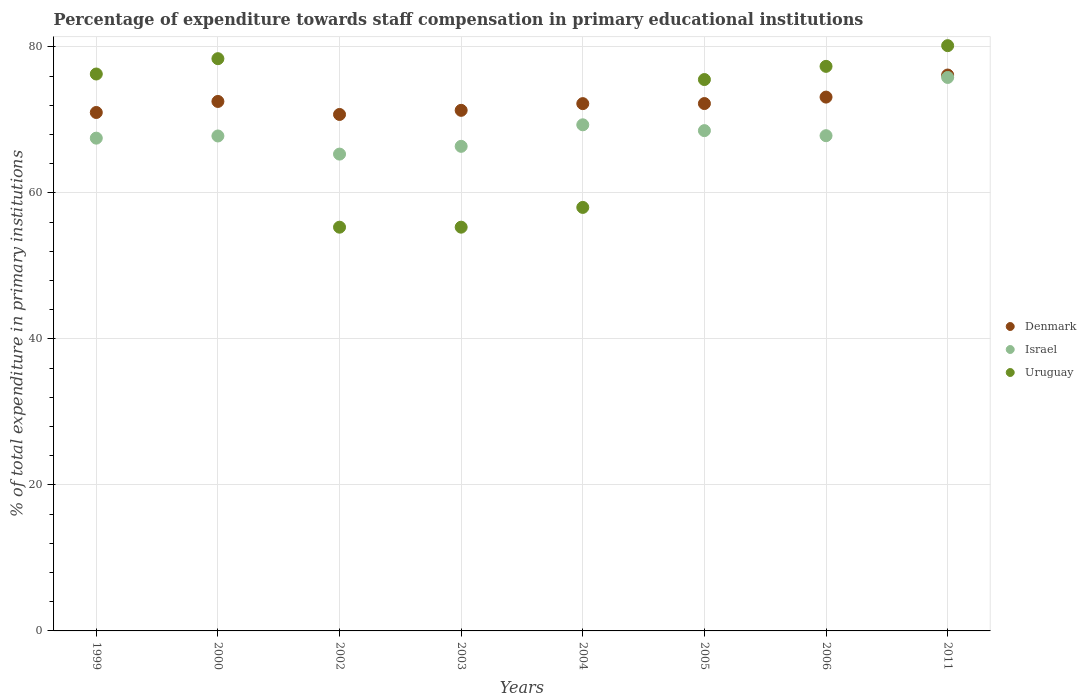How many different coloured dotlines are there?
Keep it short and to the point. 3. What is the percentage of expenditure towards staff compensation in Uruguay in 2004?
Offer a terse response. 58.01. Across all years, what is the maximum percentage of expenditure towards staff compensation in Uruguay?
Make the answer very short. 80.17. Across all years, what is the minimum percentage of expenditure towards staff compensation in Uruguay?
Provide a short and direct response. 55.3. In which year was the percentage of expenditure towards staff compensation in Uruguay maximum?
Make the answer very short. 2011. What is the total percentage of expenditure towards staff compensation in Israel in the graph?
Your response must be concise. 548.5. What is the difference between the percentage of expenditure towards staff compensation in Israel in 2002 and that in 2006?
Your response must be concise. -2.52. What is the difference between the percentage of expenditure towards staff compensation in Denmark in 2003 and the percentage of expenditure towards staff compensation in Israel in 1999?
Provide a short and direct response. 3.81. What is the average percentage of expenditure towards staff compensation in Uruguay per year?
Ensure brevity in your answer.  69.54. In the year 2003, what is the difference between the percentage of expenditure towards staff compensation in Uruguay and percentage of expenditure towards staff compensation in Israel?
Offer a very short reply. -11.07. What is the ratio of the percentage of expenditure towards staff compensation in Denmark in 2005 to that in 2011?
Your response must be concise. 0.95. Is the difference between the percentage of expenditure towards staff compensation in Uruguay in 1999 and 2004 greater than the difference between the percentage of expenditure towards staff compensation in Israel in 1999 and 2004?
Ensure brevity in your answer.  Yes. What is the difference between the highest and the second highest percentage of expenditure towards staff compensation in Israel?
Provide a succinct answer. 6.49. What is the difference between the highest and the lowest percentage of expenditure towards staff compensation in Israel?
Your answer should be compact. 10.5. Is the sum of the percentage of expenditure towards staff compensation in Denmark in 2000 and 2004 greater than the maximum percentage of expenditure towards staff compensation in Israel across all years?
Give a very brief answer. Yes. Is it the case that in every year, the sum of the percentage of expenditure towards staff compensation in Uruguay and percentage of expenditure towards staff compensation in Denmark  is greater than the percentage of expenditure towards staff compensation in Israel?
Provide a succinct answer. Yes. How many years are there in the graph?
Offer a terse response. 8. Are the values on the major ticks of Y-axis written in scientific E-notation?
Your response must be concise. No. Does the graph contain grids?
Ensure brevity in your answer.  Yes. How many legend labels are there?
Your answer should be very brief. 3. How are the legend labels stacked?
Give a very brief answer. Vertical. What is the title of the graph?
Provide a succinct answer. Percentage of expenditure towards staff compensation in primary educational institutions. Does "Ghana" appear as one of the legend labels in the graph?
Offer a very short reply. No. What is the label or title of the X-axis?
Your response must be concise. Years. What is the label or title of the Y-axis?
Provide a short and direct response. % of total expenditure in primary institutions. What is the % of total expenditure in primary institutions of Denmark in 1999?
Make the answer very short. 71.01. What is the % of total expenditure in primary institutions in Israel in 1999?
Provide a short and direct response. 67.5. What is the % of total expenditure in primary institutions of Uruguay in 1999?
Your answer should be very brief. 76.29. What is the % of total expenditure in primary institutions in Denmark in 2000?
Offer a very short reply. 72.53. What is the % of total expenditure in primary institutions of Israel in 2000?
Your answer should be compact. 67.8. What is the % of total expenditure in primary institutions of Uruguay in 2000?
Provide a short and direct response. 78.39. What is the % of total expenditure in primary institutions of Denmark in 2002?
Your answer should be compact. 70.75. What is the % of total expenditure in primary institutions of Israel in 2002?
Keep it short and to the point. 65.31. What is the % of total expenditure in primary institutions in Uruguay in 2002?
Your response must be concise. 55.3. What is the % of total expenditure in primary institutions in Denmark in 2003?
Make the answer very short. 71.31. What is the % of total expenditure in primary institutions in Israel in 2003?
Provide a short and direct response. 66.38. What is the % of total expenditure in primary institutions of Uruguay in 2003?
Make the answer very short. 55.31. What is the % of total expenditure in primary institutions of Denmark in 2004?
Your response must be concise. 72.23. What is the % of total expenditure in primary institutions in Israel in 2004?
Make the answer very short. 69.33. What is the % of total expenditure in primary institutions of Uruguay in 2004?
Your answer should be very brief. 58.01. What is the % of total expenditure in primary institutions of Denmark in 2005?
Keep it short and to the point. 72.24. What is the % of total expenditure in primary institutions in Israel in 2005?
Your answer should be compact. 68.53. What is the % of total expenditure in primary institutions in Uruguay in 2005?
Keep it short and to the point. 75.53. What is the % of total expenditure in primary institutions of Denmark in 2006?
Make the answer very short. 73.12. What is the % of total expenditure in primary institutions in Israel in 2006?
Provide a short and direct response. 67.84. What is the % of total expenditure in primary institutions of Uruguay in 2006?
Offer a terse response. 77.33. What is the % of total expenditure in primary institutions of Denmark in 2011?
Your answer should be very brief. 76.15. What is the % of total expenditure in primary institutions of Israel in 2011?
Your response must be concise. 75.82. What is the % of total expenditure in primary institutions in Uruguay in 2011?
Your answer should be very brief. 80.17. Across all years, what is the maximum % of total expenditure in primary institutions in Denmark?
Offer a terse response. 76.15. Across all years, what is the maximum % of total expenditure in primary institutions in Israel?
Offer a very short reply. 75.82. Across all years, what is the maximum % of total expenditure in primary institutions of Uruguay?
Provide a short and direct response. 80.17. Across all years, what is the minimum % of total expenditure in primary institutions in Denmark?
Offer a very short reply. 70.75. Across all years, what is the minimum % of total expenditure in primary institutions of Israel?
Offer a very short reply. 65.31. Across all years, what is the minimum % of total expenditure in primary institutions in Uruguay?
Offer a terse response. 55.3. What is the total % of total expenditure in primary institutions in Denmark in the graph?
Ensure brevity in your answer.  579.33. What is the total % of total expenditure in primary institutions of Israel in the graph?
Make the answer very short. 548.5. What is the total % of total expenditure in primary institutions in Uruguay in the graph?
Your response must be concise. 556.32. What is the difference between the % of total expenditure in primary institutions of Denmark in 1999 and that in 2000?
Ensure brevity in your answer.  -1.51. What is the difference between the % of total expenditure in primary institutions of Israel in 1999 and that in 2000?
Ensure brevity in your answer.  -0.3. What is the difference between the % of total expenditure in primary institutions in Uruguay in 1999 and that in 2000?
Keep it short and to the point. -2.1. What is the difference between the % of total expenditure in primary institutions of Denmark in 1999 and that in 2002?
Your response must be concise. 0.27. What is the difference between the % of total expenditure in primary institutions of Israel in 1999 and that in 2002?
Provide a short and direct response. 2.18. What is the difference between the % of total expenditure in primary institutions of Uruguay in 1999 and that in 2002?
Give a very brief answer. 20.98. What is the difference between the % of total expenditure in primary institutions of Denmark in 1999 and that in 2003?
Your response must be concise. -0.3. What is the difference between the % of total expenditure in primary institutions of Israel in 1999 and that in 2003?
Your response must be concise. 1.12. What is the difference between the % of total expenditure in primary institutions in Uruguay in 1999 and that in 2003?
Ensure brevity in your answer.  20.98. What is the difference between the % of total expenditure in primary institutions of Denmark in 1999 and that in 2004?
Make the answer very short. -1.21. What is the difference between the % of total expenditure in primary institutions of Israel in 1999 and that in 2004?
Make the answer very short. -1.83. What is the difference between the % of total expenditure in primary institutions of Uruguay in 1999 and that in 2004?
Provide a succinct answer. 18.27. What is the difference between the % of total expenditure in primary institutions of Denmark in 1999 and that in 2005?
Your answer should be compact. -1.22. What is the difference between the % of total expenditure in primary institutions of Israel in 1999 and that in 2005?
Your answer should be compact. -1.03. What is the difference between the % of total expenditure in primary institutions in Uruguay in 1999 and that in 2005?
Your answer should be very brief. 0.76. What is the difference between the % of total expenditure in primary institutions of Denmark in 1999 and that in 2006?
Keep it short and to the point. -2.11. What is the difference between the % of total expenditure in primary institutions of Israel in 1999 and that in 2006?
Your response must be concise. -0.34. What is the difference between the % of total expenditure in primary institutions in Uruguay in 1999 and that in 2006?
Offer a terse response. -1.05. What is the difference between the % of total expenditure in primary institutions of Denmark in 1999 and that in 2011?
Offer a terse response. -5.13. What is the difference between the % of total expenditure in primary institutions in Israel in 1999 and that in 2011?
Provide a succinct answer. -8.32. What is the difference between the % of total expenditure in primary institutions in Uruguay in 1999 and that in 2011?
Your answer should be very brief. -3.88. What is the difference between the % of total expenditure in primary institutions in Denmark in 2000 and that in 2002?
Keep it short and to the point. 1.78. What is the difference between the % of total expenditure in primary institutions of Israel in 2000 and that in 2002?
Your answer should be compact. 2.48. What is the difference between the % of total expenditure in primary institutions of Uruguay in 2000 and that in 2002?
Offer a terse response. 23.08. What is the difference between the % of total expenditure in primary institutions of Denmark in 2000 and that in 2003?
Your answer should be compact. 1.22. What is the difference between the % of total expenditure in primary institutions of Israel in 2000 and that in 2003?
Keep it short and to the point. 1.42. What is the difference between the % of total expenditure in primary institutions in Uruguay in 2000 and that in 2003?
Make the answer very short. 23.08. What is the difference between the % of total expenditure in primary institutions of Denmark in 2000 and that in 2004?
Provide a succinct answer. 0.3. What is the difference between the % of total expenditure in primary institutions of Israel in 2000 and that in 2004?
Your answer should be compact. -1.53. What is the difference between the % of total expenditure in primary institutions of Uruguay in 2000 and that in 2004?
Offer a very short reply. 20.37. What is the difference between the % of total expenditure in primary institutions in Denmark in 2000 and that in 2005?
Give a very brief answer. 0.29. What is the difference between the % of total expenditure in primary institutions in Israel in 2000 and that in 2005?
Offer a terse response. -0.73. What is the difference between the % of total expenditure in primary institutions of Uruguay in 2000 and that in 2005?
Ensure brevity in your answer.  2.86. What is the difference between the % of total expenditure in primary institutions in Denmark in 2000 and that in 2006?
Your response must be concise. -0.6. What is the difference between the % of total expenditure in primary institutions of Israel in 2000 and that in 2006?
Ensure brevity in your answer.  -0.04. What is the difference between the % of total expenditure in primary institutions of Uruguay in 2000 and that in 2006?
Keep it short and to the point. 1.05. What is the difference between the % of total expenditure in primary institutions of Denmark in 2000 and that in 2011?
Offer a very short reply. -3.62. What is the difference between the % of total expenditure in primary institutions of Israel in 2000 and that in 2011?
Your answer should be compact. -8.02. What is the difference between the % of total expenditure in primary institutions of Uruguay in 2000 and that in 2011?
Your answer should be compact. -1.78. What is the difference between the % of total expenditure in primary institutions in Denmark in 2002 and that in 2003?
Provide a succinct answer. -0.56. What is the difference between the % of total expenditure in primary institutions in Israel in 2002 and that in 2003?
Offer a very short reply. -1.06. What is the difference between the % of total expenditure in primary institutions in Uruguay in 2002 and that in 2003?
Your response must be concise. -0. What is the difference between the % of total expenditure in primary institutions of Denmark in 2002 and that in 2004?
Offer a very short reply. -1.48. What is the difference between the % of total expenditure in primary institutions in Israel in 2002 and that in 2004?
Provide a short and direct response. -4.01. What is the difference between the % of total expenditure in primary institutions in Uruguay in 2002 and that in 2004?
Offer a terse response. -2.71. What is the difference between the % of total expenditure in primary institutions of Denmark in 2002 and that in 2005?
Your response must be concise. -1.49. What is the difference between the % of total expenditure in primary institutions of Israel in 2002 and that in 2005?
Your answer should be compact. -3.21. What is the difference between the % of total expenditure in primary institutions of Uruguay in 2002 and that in 2005?
Ensure brevity in your answer.  -20.22. What is the difference between the % of total expenditure in primary institutions of Denmark in 2002 and that in 2006?
Provide a short and direct response. -2.38. What is the difference between the % of total expenditure in primary institutions of Israel in 2002 and that in 2006?
Provide a succinct answer. -2.52. What is the difference between the % of total expenditure in primary institutions of Uruguay in 2002 and that in 2006?
Give a very brief answer. -22.03. What is the difference between the % of total expenditure in primary institutions in Denmark in 2002 and that in 2011?
Keep it short and to the point. -5.4. What is the difference between the % of total expenditure in primary institutions of Israel in 2002 and that in 2011?
Provide a short and direct response. -10.5. What is the difference between the % of total expenditure in primary institutions in Uruguay in 2002 and that in 2011?
Offer a very short reply. -24.87. What is the difference between the % of total expenditure in primary institutions in Denmark in 2003 and that in 2004?
Offer a very short reply. -0.92. What is the difference between the % of total expenditure in primary institutions of Israel in 2003 and that in 2004?
Your answer should be compact. -2.95. What is the difference between the % of total expenditure in primary institutions of Uruguay in 2003 and that in 2004?
Offer a very short reply. -2.71. What is the difference between the % of total expenditure in primary institutions of Denmark in 2003 and that in 2005?
Give a very brief answer. -0.93. What is the difference between the % of total expenditure in primary institutions of Israel in 2003 and that in 2005?
Ensure brevity in your answer.  -2.15. What is the difference between the % of total expenditure in primary institutions in Uruguay in 2003 and that in 2005?
Your answer should be very brief. -20.22. What is the difference between the % of total expenditure in primary institutions in Denmark in 2003 and that in 2006?
Keep it short and to the point. -1.81. What is the difference between the % of total expenditure in primary institutions in Israel in 2003 and that in 2006?
Ensure brevity in your answer.  -1.46. What is the difference between the % of total expenditure in primary institutions in Uruguay in 2003 and that in 2006?
Your answer should be very brief. -22.03. What is the difference between the % of total expenditure in primary institutions in Denmark in 2003 and that in 2011?
Provide a short and direct response. -4.84. What is the difference between the % of total expenditure in primary institutions of Israel in 2003 and that in 2011?
Offer a terse response. -9.44. What is the difference between the % of total expenditure in primary institutions of Uruguay in 2003 and that in 2011?
Your answer should be compact. -24.86. What is the difference between the % of total expenditure in primary institutions of Denmark in 2004 and that in 2005?
Your answer should be compact. -0.01. What is the difference between the % of total expenditure in primary institutions of Israel in 2004 and that in 2005?
Provide a short and direct response. 0.8. What is the difference between the % of total expenditure in primary institutions in Uruguay in 2004 and that in 2005?
Your answer should be very brief. -17.52. What is the difference between the % of total expenditure in primary institutions in Denmark in 2004 and that in 2006?
Provide a succinct answer. -0.89. What is the difference between the % of total expenditure in primary institutions of Israel in 2004 and that in 2006?
Offer a very short reply. 1.49. What is the difference between the % of total expenditure in primary institutions in Uruguay in 2004 and that in 2006?
Provide a succinct answer. -19.32. What is the difference between the % of total expenditure in primary institutions of Denmark in 2004 and that in 2011?
Your answer should be very brief. -3.92. What is the difference between the % of total expenditure in primary institutions in Israel in 2004 and that in 2011?
Make the answer very short. -6.49. What is the difference between the % of total expenditure in primary institutions of Uruguay in 2004 and that in 2011?
Offer a very short reply. -22.16. What is the difference between the % of total expenditure in primary institutions of Denmark in 2005 and that in 2006?
Keep it short and to the point. -0.88. What is the difference between the % of total expenditure in primary institutions in Israel in 2005 and that in 2006?
Offer a very short reply. 0.69. What is the difference between the % of total expenditure in primary institutions of Uruguay in 2005 and that in 2006?
Make the answer very short. -1.81. What is the difference between the % of total expenditure in primary institutions of Denmark in 2005 and that in 2011?
Your answer should be compact. -3.91. What is the difference between the % of total expenditure in primary institutions of Israel in 2005 and that in 2011?
Your response must be concise. -7.29. What is the difference between the % of total expenditure in primary institutions of Uruguay in 2005 and that in 2011?
Offer a very short reply. -4.64. What is the difference between the % of total expenditure in primary institutions of Denmark in 2006 and that in 2011?
Give a very brief answer. -3.02. What is the difference between the % of total expenditure in primary institutions in Israel in 2006 and that in 2011?
Your answer should be very brief. -7.98. What is the difference between the % of total expenditure in primary institutions in Uruguay in 2006 and that in 2011?
Keep it short and to the point. -2.84. What is the difference between the % of total expenditure in primary institutions of Denmark in 1999 and the % of total expenditure in primary institutions of Israel in 2000?
Provide a succinct answer. 3.22. What is the difference between the % of total expenditure in primary institutions of Denmark in 1999 and the % of total expenditure in primary institutions of Uruguay in 2000?
Your answer should be compact. -7.37. What is the difference between the % of total expenditure in primary institutions of Israel in 1999 and the % of total expenditure in primary institutions of Uruguay in 2000?
Your response must be concise. -10.89. What is the difference between the % of total expenditure in primary institutions in Denmark in 1999 and the % of total expenditure in primary institutions in Israel in 2002?
Your answer should be very brief. 5.7. What is the difference between the % of total expenditure in primary institutions of Denmark in 1999 and the % of total expenditure in primary institutions of Uruguay in 2002?
Ensure brevity in your answer.  15.71. What is the difference between the % of total expenditure in primary institutions in Israel in 1999 and the % of total expenditure in primary institutions in Uruguay in 2002?
Provide a succinct answer. 12.2. What is the difference between the % of total expenditure in primary institutions of Denmark in 1999 and the % of total expenditure in primary institutions of Israel in 2003?
Provide a succinct answer. 4.64. What is the difference between the % of total expenditure in primary institutions of Denmark in 1999 and the % of total expenditure in primary institutions of Uruguay in 2003?
Offer a very short reply. 15.71. What is the difference between the % of total expenditure in primary institutions of Israel in 1999 and the % of total expenditure in primary institutions of Uruguay in 2003?
Provide a succinct answer. 12.19. What is the difference between the % of total expenditure in primary institutions of Denmark in 1999 and the % of total expenditure in primary institutions of Israel in 2004?
Provide a succinct answer. 1.69. What is the difference between the % of total expenditure in primary institutions in Denmark in 1999 and the % of total expenditure in primary institutions in Uruguay in 2004?
Give a very brief answer. 13. What is the difference between the % of total expenditure in primary institutions of Israel in 1999 and the % of total expenditure in primary institutions of Uruguay in 2004?
Your answer should be very brief. 9.49. What is the difference between the % of total expenditure in primary institutions in Denmark in 1999 and the % of total expenditure in primary institutions in Israel in 2005?
Give a very brief answer. 2.49. What is the difference between the % of total expenditure in primary institutions in Denmark in 1999 and the % of total expenditure in primary institutions in Uruguay in 2005?
Your response must be concise. -4.51. What is the difference between the % of total expenditure in primary institutions in Israel in 1999 and the % of total expenditure in primary institutions in Uruguay in 2005?
Ensure brevity in your answer.  -8.03. What is the difference between the % of total expenditure in primary institutions of Denmark in 1999 and the % of total expenditure in primary institutions of Israel in 2006?
Make the answer very short. 3.18. What is the difference between the % of total expenditure in primary institutions of Denmark in 1999 and the % of total expenditure in primary institutions of Uruguay in 2006?
Provide a succinct answer. -6.32. What is the difference between the % of total expenditure in primary institutions in Israel in 1999 and the % of total expenditure in primary institutions in Uruguay in 2006?
Offer a very short reply. -9.83. What is the difference between the % of total expenditure in primary institutions in Denmark in 1999 and the % of total expenditure in primary institutions in Israel in 2011?
Your answer should be very brief. -4.8. What is the difference between the % of total expenditure in primary institutions of Denmark in 1999 and the % of total expenditure in primary institutions of Uruguay in 2011?
Your answer should be compact. -9.16. What is the difference between the % of total expenditure in primary institutions of Israel in 1999 and the % of total expenditure in primary institutions of Uruguay in 2011?
Make the answer very short. -12.67. What is the difference between the % of total expenditure in primary institutions of Denmark in 2000 and the % of total expenditure in primary institutions of Israel in 2002?
Ensure brevity in your answer.  7.21. What is the difference between the % of total expenditure in primary institutions in Denmark in 2000 and the % of total expenditure in primary institutions in Uruguay in 2002?
Offer a very short reply. 17.22. What is the difference between the % of total expenditure in primary institutions in Israel in 2000 and the % of total expenditure in primary institutions in Uruguay in 2002?
Make the answer very short. 12.49. What is the difference between the % of total expenditure in primary institutions in Denmark in 2000 and the % of total expenditure in primary institutions in Israel in 2003?
Keep it short and to the point. 6.15. What is the difference between the % of total expenditure in primary institutions of Denmark in 2000 and the % of total expenditure in primary institutions of Uruguay in 2003?
Make the answer very short. 17.22. What is the difference between the % of total expenditure in primary institutions in Israel in 2000 and the % of total expenditure in primary institutions in Uruguay in 2003?
Keep it short and to the point. 12.49. What is the difference between the % of total expenditure in primary institutions in Denmark in 2000 and the % of total expenditure in primary institutions in Israel in 2004?
Offer a very short reply. 3.2. What is the difference between the % of total expenditure in primary institutions of Denmark in 2000 and the % of total expenditure in primary institutions of Uruguay in 2004?
Your answer should be very brief. 14.52. What is the difference between the % of total expenditure in primary institutions in Israel in 2000 and the % of total expenditure in primary institutions in Uruguay in 2004?
Your answer should be compact. 9.79. What is the difference between the % of total expenditure in primary institutions in Denmark in 2000 and the % of total expenditure in primary institutions in Israel in 2005?
Give a very brief answer. 4. What is the difference between the % of total expenditure in primary institutions in Denmark in 2000 and the % of total expenditure in primary institutions in Uruguay in 2005?
Your answer should be very brief. -3. What is the difference between the % of total expenditure in primary institutions of Israel in 2000 and the % of total expenditure in primary institutions of Uruguay in 2005?
Keep it short and to the point. -7.73. What is the difference between the % of total expenditure in primary institutions in Denmark in 2000 and the % of total expenditure in primary institutions in Israel in 2006?
Your answer should be very brief. 4.69. What is the difference between the % of total expenditure in primary institutions in Denmark in 2000 and the % of total expenditure in primary institutions in Uruguay in 2006?
Provide a short and direct response. -4.81. What is the difference between the % of total expenditure in primary institutions of Israel in 2000 and the % of total expenditure in primary institutions of Uruguay in 2006?
Your answer should be very brief. -9.54. What is the difference between the % of total expenditure in primary institutions of Denmark in 2000 and the % of total expenditure in primary institutions of Israel in 2011?
Provide a succinct answer. -3.29. What is the difference between the % of total expenditure in primary institutions in Denmark in 2000 and the % of total expenditure in primary institutions in Uruguay in 2011?
Give a very brief answer. -7.64. What is the difference between the % of total expenditure in primary institutions of Israel in 2000 and the % of total expenditure in primary institutions of Uruguay in 2011?
Your answer should be compact. -12.37. What is the difference between the % of total expenditure in primary institutions of Denmark in 2002 and the % of total expenditure in primary institutions of Israel in 2003?
Offer a very short reply. 4.37. What is the difference between the % of total expenditure in primary institutions in Denmark in 2002 and the % of total expenditure in primary institutions in Uruguay in 2003?
Offer a terse response. 15.44. What is the difference between the % of total expenditure in primary institutions in Israel in 2002 and the % of total expenditure in primary institutions in Uruguay in 2003?
Keep it short and to the point. 10.01. What is the difference between the % of total expenditure in primary institutions in Denmark in 2002 and the % of total expenditure in primary institutions in Israel in 2004?
Provide a succinct answer. 1.42. What is the difference between the % of total expenditure in primary institutions in Denmark in 2002 and the % of total expenditure in primary institutions in Uruguay in 2004?
Keep it short and to the point. 12.73. What is the difference between the % of total expenditure in primary institutions of Israel in 2002 and the % of total expenditure in primary institutions of Uruguay in 2004?
Your response must be concise. 7.3. What is the difference between the % of total expenditure in primary institutions in Denmark in 2002 and the % of total expenditure in primary institutions in Israel in 2005?
Provide a short and direct response. 2.22. What is the difference between the % of total expenditure in primary institutions of Denmark in 2002 and the % of total expenditure in primary institutions of Uruguay in 2005?
Provide a succinct answer. -4.78. What is the difference between the % of total expenditure in primary institutions in Israel in 2002 and the % of total expenditure in primary institutions in Uruguay in 2005?
Offer a very short reply. -10.21. What is the difference between the % of total expenditure in primary institutions in Denmark in 2002 and the % of total expenditure in primary institutions in Israel in 2006?
Offer a terse response. 2.91. What is the difference between the % of total expenditure in primary institutions in Denmark in 2002 and the % of total expenditure in primary institutions in Uruguay in 2006?
Your answer should be compact. -6.59. What is the difference between the % of total expenditure in primary institutions in Israel in 2002 and the % of total expenditure in primary institutions in Uruguay in 2006?
Make the answer very short. -12.02. What is the difference between the % of total expenditure in primary institutions of Denmark in 2002 and the % of total expenditure in primary institutions of Israel in 2011?
Give a very brief answer. -5.07. What is the difference between the % of total expenditure in primary institutions in Denmark in 2002 and the % of total expenditure in primary institutions in Uruguay in 2011?
Your response must be concise. -9.42. What is the difference between the % of total expenditure in primary institutions in Israel in 2002 and the % of total expenditure in primary institutions in Uruguay in 2011?
Provide a succinct answer. -14.86. What is the difference between the % of total expenditure in primary institutions in Denmark in 2003 and the % of total expenditure in primary institutions in Israel in 2004?
Offer a very short reply. 1.98. What is the difference between the % of total expenditure in primary institutions in Denmark in 2003 and the % of total expenditure in primary institutions in Uruguay in 2004?
Provide a short and direct response. 13.3. What is the difference between the % of total expenditure in primary institutions in Israel in 2003 and the % of total expenditure in primary institutions in Uruguay in 2004?
Make the answer very short. 8.37. What is the difference between the % of total expenditure in primary institutions in Denmark in 2003 and the % of total expenditure in primary institutions in Israel in 2005?
Offer a very short reply. 2.78. What is the difference between the % of total expenditure in primary institutions in Denmark in 2003 and the % of total expenditure in primary institutions in Uruguay in 2005?
Provide a short and direct response. -4.22. What is the difference between the % of total expenditure in primary institutions in Israel in 2003 and the % of total expenditure in primary institutions in Uruguay in 2005?
Provide a short and direct response. -9.15. What is the difference between the % of total expenditure in primary institutions in Denmark in 2003 and the % of total expenditure in primary institutions in Israel in 2006?
Offer a very short reply. 3.47. What is the difference between the % of total expenditure in primary institutions of Denmark in 2003 and the % of total expenditure in primary institutions of Uruguay in 2006?
Offer a very short reply. -6.02. What is the difference between the % of total expenditure in primary institutions in Israel in 2003 and the % of total expenditure in primary institutions in Uruguay in 2006?
Give a very brief answer. -10.96. What is the difference between the % of total expenditure in primary institutions in Denmark in 2003 and the % of total expenditure in primary institutions in Israel in 2011?
Offer a terse response. -4.51. What is the difference between the % of total expenditure in primary institutions of Denmark in 2003 and the % of total expenditure in primary institutions of Uruguay in 2011?
Make the answer very short. -8.86. What is the difference between the % of total expenditure in primary institutions in Israel in 2003 and the % of total expenditure in primary institutions in Uruguay in 2011?
Offer a very short reply. -13.79. What is the difference between the % of total expenditure in primary institutions of Denmark in 2004 and the % of total expenditure in primary institutions of Israel in 2005?
Keep it short and to the point. 3.7. What is the difference between the % of total expenditure in primary institutions of Denmark in 2004 and the % of total expenditure in primary institutions of Uruguay in 2005?
Offer a terse response. -3.3. What is the difference between the % of total expenditure in primary institutions in Israel in 2004 and the % of total expenditure in primary institutions in Uruguay in 2005?
Your answer should be very brief. -6.2. What is the difference between the % of total expenditure in primary institutions in Denmark in 2004 and the % of total expenditure in primary institutions in Israel in 2006?
Provide a succinct answer. 4.39. What is the difference between the % of total expenditure in primary institutions of Denmark in 2004 and the % of total expenditure in primary institutions of Uruguay in 2006?
Provide a short and direct response. -5.11. What is the difference between the % of total expenditure in primary institutions of Israel in 2004 and the % of total expenditure in primary institutions of Uruguay in 2006?
Offer a terse response. -8.01. What is the difference between the % of total expenditure in primary institutions in Denmark in 2004 and the % of total expenditure in primary institutions in Israel in 2011?
Ensure brevity in your answer.  -3.59. What is the difference between the % of total expenditure in primary institutions of Denmark in 2004 and the % of total expenditure in primary institutions of Uruguay in 2011?
Keep it short and to the point. -7.94. What is the difference between the % of total expenditure in primary institutions in Israel in 2004 and the % of total expenditure in primary institutions in Uruguay in 2011?
Give a very brief answer. -10.84. What is the difference between the % of total expenditure in primary institutions in Denmark in 2005 and the % of total expenditure in primary institutions in Israel in 2006?
Your response must be concise. 4.4. What is the difference between the % of total expenditure in primary institutions in Denmark in 2005 and the % of total expenditure in primary institutions in Uruguay in 2006?
Your answer should be very brief. -5.1. What is the difference between the % of total expenditure in primary institutions of Israel in 2005 and the % of total expenditure in primary institutions of Uruguay in 2006?
Your answer should be compact. -8.81. What is the difference between the % of total expenditure in primary institutions of Denmark in 2005 and the % of total expenditure in primary institutions of Israel in 2011?
Make the answer very short. -3.58. What is the difference between the % of total expenditure in primary institutions in Denmark in 2005 and the % of total expenditure in primary institutions in Uruguay in 2011?
Provide a succinct answer. -7.93. What is the difference between the % of total expenditure in primary institutions of Israel in 2005 and the % of total expenditure in primary institutions of Uruguay in 2011?
Provide a short and direct response. -11.64. What is the difference between the % of total expenditure in primary institutions in Denmark in 2006 and the % of total expenditure in primary institutions in Israel in 2011?
Your answer should be compact. -2.69. What is the difference between the % of total expenditure in primary institutions in Denmark in 2006 and the % of total expenditure in primary institutions in Uruguay in 2011?
Give a very brief answer. -7.05. What is the difference between the % of total expenditure in primary institutions of Israel in 2006 and the % of total expenditure in primary institutions of Uruguay in 2011?
Provide a short and direct response. -12.33. What is the average % of total expenditure in primary institutions of Denmark per year?
Keep it short and to the point. 72.42. What is the average % of total expenditure in primary institutions in Israel per year?
Offer a very short reply. 68.56. What is the average % of total expenditure in primary institutions of Uruguay per year?
Offer a terse response. 69.54. In the year 1999, what is the difference between the % of total expenditure in primary institutions in Denmark and % of total expenditure in primary institutions in Israel?
Offer a terse response. 3.52. In the year 1999, what is the difference between the % of total expenditure in primary institutions of Denmark and % of total expenditure in primary institutions of Uruguay?
Your answer should be compact. -5.27. In the year 1999, what is the difference between the % of total expenditure in primary institutions of Israel and % of total expenditure in primary institutions of Uruguay?
Give a very brief answer. -8.79. In the year 2000, what is the difference between the % of total expenditure in primary institutions in Denmark and % of total expenditure in primary institutions in Israel?
Offer a terse response. 4.73. In the year 2000, what is the difference between the % of total expenditure in primary institutions of Denmark and % of total expenditure in primary institutions of Uruguay?
Offer a very short reply. -5.86. In the year 2000, what is the difference between the % of total expenditure in primary institutions of Israel and % of total expenditure in primary institutions of Uruguay?
Give a very brief answer. -10.59. In the year 2002, what is the difference between the % of total expenditure in primary institutions in Denmark and % of total expenditure in primary institutions in Israel?
Keep it short and to the point. 5.43. In the year 2002, what is the difference between the % of total expenditure in primary institutions in Denmark and % of total expenditure in primary institutions in Uruguay?
Keep it short and to the point. 15.44. In the year 2002, what is the difference between the % of total expenditure in primary institutions in Israel and % of total expenditure in primary institutions in Uruguay?
Ensure brevity in your answer.  10.01. In the year 2003, what is the difference between the % of total expenditure in primary institutions in Denmark and % of total expenditure in primary institutions in Israel?
Your answer should be very brief. 4.93. In the year 2003, what is the difference between the % of total expenditure in primary institutions of Denmark and % of total expenditure in primary institutions of Uruguay?
Provide a succinct answer. 16. In the year 2003, what is the difference between the % of total expenditure in primary institutions in Israel and % of total expenditure in primary institutions in Uruguay?
Provide a short and direct response. 11.07. In the year 2004, what is the difference between the % of total expenditure in primary institutions of Denmark and % of total expenditure in primary institutions of Israel?
Your answer should be compact. 2.9. In the year 2004, what is the difference between the % of total expenditure in primary institutions of Denmark and % of total expenditure in primary institutions of Uruguay?
Make the answer very short. 14.22. In the year 2004, what is the difference between the % of total expenditure in primary institutions of Israel and % of total expenditure in primary institutions of Uruguay?
Ensure brevity in your answer.  11.32. In the year 2005, what is the difference between the % of total expenditure in primary institutions of Denmark and % of total expenditure in primary institutions of Israel?
Keep it short and to the point. 3.71. In the year 2005, what is the difference between the % of total expenditure in primary institutions in Denmark and % of total expenditure in primary institutions in Uruguay?
Make the answer very short. -3.29. In the year 2005, what is the difference between the % of total expenditure in primary institutions of Israel and % of total expenditure in primary institutions of Uruguay?
Keep it short and to the point. -7. In the year 2006, what is the difference between the % of total expenditure in primary institutions of Denmark and % of total expenditure in primary institutions of Israel?
Your answer should be compact. 5.29. In the year 2006, what is the difference between the % of total expenditure in primary institutions of Denmark and % of total expenditure in primary institutions of Uruguay?
Provide a succinct answer. -4.21. In the year 2006, what is the difference between the % of total expenditure in primary institutions of Israel and % of total expenditure in primary institutions of Uruguay?
Provide a short and direct response. -9.5. In the year 2011, what is the difference between the % of total expenditure in primary institutions in Denmark and % of total expenditure in primary institutions in Israel?
Provide a short and direct response. 0.33. In the year 2011, what is the difference between the % of total expenditure in primary institutions of Denmark and % of total expenditure in primary institutions of Uruguay?
Offer a very short reply. -4.02. In the year 2011, what is the difference between the % of total expenditure in primary institutions in Israel and % of total expenditure in primary institutions in Uruguay?
Ensure brevity in your answer.  -4.35. What is the ratio of the % of total expenditure in primary institutions of Denmark in 1999 to that in 2000?
Provide a succinct answer. 0.98. What is the ratio of the % of total expenditure in primary institutions of Uruguay in 1999 to that in 2000?
Your answer should be very brief. 0.97. What is the ratio of the % of total expenditure in primary institutions of Israel in 1999 to that in 2002?
Provide a short and direct response. 1.03. What is the ratio of the % of total expenditure in primary institutions of Uruguay in 1999 to that in 2002?
Offer a very short reply. 1.38. What is the ratio of the % of total expenditure in primary institutions in Denmark in 1999 to that in 2003?
Keep it short and to the point. 1. What is the ratio of the % of total expenditure in primary institutions in Israel in 1999 to that in 2003?
Provide a succinct answer. 1.02. What is the ratio of the % of total expenditure in primary institutions of Uruguay in 1999 to that in 2003?
Give a very brief answer. 1.38. What is the ratio of the % of total expenditure in primary institutions in Denmark in 1999 to that in 2004?
Ensure brevity in your answer.  0.98. What is the ratio of the % of total expenditure in primary institutions in Israel in 1999 to that in 2004?
Make the answer very short. 0.97. What is the ratio of the % of total expenditure in primary institutions of Uruguay in 1999 to that in 2004?
Ensure brevity in your answer.  1.31. What is the ratio of the % of total expenditure in primary institutions of Denmark in 1999 to that in 2005?
Give a very brief answer. 0.98. What is the ratio of the % of total expenditure in primary institutions of Israel in 1999 to that in 2005?
Your response must be concise. 0.98. What is the ratio of the % of total expenditure in primary institutions of Uruguay in 1999 to that in 2005?
Your answer should be compact. 1.01. What is the ratio of the % of total expenditure in primary institutions in Denmark in 1999 to that in 2006?
Provide a short and direct response. 0.97. What is the ratio of the % of total expenditure in primary institutions of Israel in 1999 to that in 2006?
Your response must be concise. 0.99. What is the ratio of the % of total expenditure in primary institutions of Uruguay in 1999 to that in 2006?
Ensure brevity in your answer.  0.99. What is the ratio of the % of total expenditure in primary institutions of Denmark in 1999 to that in 2011?
Offer a terse response. 0.93. What is the ratio of the % of total expenditure in primary institutions in Israel in 1999 to that in 2011?
Provide a succinct answer. 0.89. What is the ratio of the % of total expenditure in primary institutions in Uruguay in 1999 to that in 2011?
Make the answer very short. 0.95. What is the ratio of the % of total expenditure in primary institutions of Denmark in 2000 to that in 2002?
Your response must be concise. 1.03. What is the ratio of the % of total expenditure in primary institutions of Israel in 2000 to that in 2002?
Make the answer very short. 1.04. What is the ratio of the % of total expenditure in primary institutions in Uruguay in 2000 to that in 2002?
Give a very brief answer. 1.42. What is the ratio of the % of total expenditure in primary institutions in Denmark in 2000 to that in 2003?
Offer a very short reply. 1.02. What is the ratio of the % of total expenditure in primary institutions of Israel in 2000 to that in 2003?
Give a very brief answer. 1.02. What is the ratio of the % of total expenditure in primary institutions of Uruguay in 2000 to that in 2003?
Make the answer very short. 1.42. What is the ratio of the % of total expenditure in primary institutions in Israel in 2000 to that in 2004?
Your response must be concise. 0.98. What is the ratio of the % of total expenditure in primary institutions in Uruguay in 2000 to that in 2004?
Your answer should be very brief. 1.35. What is the ratio of the % of total expenditure in primary institutions of Israel in 2000 to that in 2005?
Ensure brevity in your answer.  0.99. What is the ratio of the % of total expenditure in primary institutions in Uruguay in 2000 to that in 2005?
Give a very brief answer. 1.04. What is the ratio of the % of total expenditure in primary institutions in Denmark in 2000 to that in 2006?
Your answer should be very brief. 0.99. What is the ratio of the % of total expenditure in primary institutions in Israel in 2000 to that in 2006?
Your response must be concise. 1. What is the ratio of the % of total expenditure in primary institutions of Uruguay in 2000 to that in 2006?
Provide a succinct answer. 1.01. What is the ratio of the % of total expenditure in primary institutions of Denmark in 2000 to that in 2011?
Your answer should be compact. 0.95. What is the ratio of the % of total expenditure in primary institutions in Israel in 2000 to that in 2011?
Keep it short and to the point. 0.89. What is the ratio of the % of total expenditure in primary institutions in Uruguay in 2000 to that in 2011?
Your answer should be compact. 0.98. What is the ratio of the % of total expenditure in primary institutions of Denmark in 2002 to that in 2003?
Your answer should be very brief. 0.99. What is the ratio of the % of total expenditure in primary institutions of Israel in 2002 to that in 2003?
Ensure brevity in your answer.  0.98. What is the ratio of the % of total expenditure in primary institutions of Denmark in 2002 to that in 2004?
Your response must be concise. 0.98. What is the ratio of the % of total expenditure in primary institutions in Israel in 2002 to that in 2004?
Make the answer very short. 0.94. What is the ratio of the % of total expenditure in primary institutions of Uruguay in 2002 to that in 2004?
Offer a very short reply. 0.95. What is the ratio of the % of total expenditure in primary institutions of Denmark in 2002 to that in 2005?
Keep it short and to the point. 0.98. What is the ratio of the % of total expenditure in primary institutions of Israel in 2002 to that in 2005?
Give a very brief answer. 0.95. What is the ratio of the % of total expenditure in primary institutions of Uruguay in 2002 to that in 2005?
Provide a succinct answer. 0.73. What is the ratio of the % of total expenditure in primary institutions of Denmark in 2002 to that in 2006?
Make the answer very short. 0.97. What is the ratio of the % of total expenditure in primary institutions in Israel in 2002 to that in 2006?
Provide a short and direct response. 0.96. What is the ratio of the % of total expenditure in primary institutions in Uruguay in 2002 to that in 2006?
Provide a short and direct response. 0.72. What is the ratio of the % of total expenditure in primary institutions of Denmark in 2002 to that in 2011?
Offer a terse response. 0.93. What is the ratio of the % of total expenditure in primary institutions in Israel in 2002 to that in 2011?
Your response must be concise. 0.86. What is the ratio of the % of total expenditure in primary institutions in Uruguay in 2002 to that in 2011?
Provide a short and direct response. 0.69. What is the ratio of the % of total expenditure in primary institutions of Denmark in 2003 to that in 2004?
Provide a succinct answer. 0.99. What is the ratio of the % of total expenditure in primary institutions in Israel in 2003 to that in 2004?
Offer a very short reply. 0.96. What is the ratio of the % of total expenditure in primary institutions of Uruguay in 2003 to that in 2004?
Provide a succinct answer. 0.95. What is the ratio of the % of total expenditure in primary institutions in Denmark in 2003 to that in 2005?
Provide a succinct answer. 0.99. What is the ratio of the % of total expenditure in primary institutions in Israel in 2003 to that in 2005?
Ensure brevity in your answer.  0.97. What is the ratio of the % of total expenditure in primary institutions of Uruguay in 2003 to that in 2005?
Keep it short and to the point. 0.73. What is the ratio of the % of total expenditure in primary institutions of Denmark in 2003 to that in 2006?
Your answer should be very brief. 0.98. What is the ratio of the % of total expenditure in primary institutions of Israel in 2003 to that in 2006?
Provide a short and direct response. 0.98. What is the ratio of the % of total expenditure in primary institutions in Uruguay in 2003 to that in 2006?
Offer a very short reply. 0.72. What is the ratio of the % of total expenditure in primary institutions of Denmark in 2003 to that in 2011?
Provide a succinct answer. 0.94. What is the ratio of the % of total expenditure in primary institutions in Israel in 2003 to that in 2011?
Offer a very short reply. 0.88. What is the ratio of the % of total expenditure in primary institutions of Uruguay in 2003 to that in 2011?
Give a very brief answer. 0.69. What is the ratio of the % of total expenditure in primary institutions in Denmark in 2004 to that in 2005?
Provide a succinct answer. 1. What is the ratio of the % of total expenditure in primary institutions in Israel in 2004 to that in 2005?
Make the answer very short. 1.01. What is the ratio of the % of total expenditure in primary institutions of Uruguay in 2004 to that in 2005?
Keep it short and to the point. 0.77. What is the ratio of the % of total expenditure in primary institutions of Denmark in 2004 to that in 2006?
Provide a short and direct response. 0.99. What is the ratio of the % of total expenditure in primary institutions in Israel in 2004 to that in 2006?
Your response must be concise. 1.02. What is the ratio of the % of total expenditure in primary institutions in Uruguay in 2004 to that in 2006?
Offer a terse response. 0.75. What is the ratio of the % of total expenditure in primary institutions in Denmark in 2004 to that in 2011?
Your response must be concise. 0.95. What is the ratio of the % of total expenditure in primary institutions of Israel in 2004 to that in 2011?
Provide a succinct answer. 0.91. What is the ratio of the % of total expenditure in primary institutions in Uruguay in 2004 to that in 2011?
Keep it short and to the point. 0.72. What is the ratio of the % of total expenditure in primary institutions in Denmark in 2005 to that in 2006?
Make the answer very short. 0.99. What is the ratio of the % of total expenditure in primary institutions of Israel in 2005 to that in 2006?
Make the answer very short. 1.01. What is the ratio of the % of total expenditure in primary institutions in Uruguay in 2005 to that in 2006?
Ensure brevity in your answer.  0.98. What is the ratio of the % of total expenditure in primary institutions of Denmark in 2005 to that in 2011?
Provide a succinct answer. 0.95. What is the ratio of the % of total expenditure in primary institutions in Israel in 2005 to that in 2011?
Provide a short and direct response. 0.9. What is the ratio of the % of total expenditure in primary institutions in Uruguay in 2005 to that in 2011?
Your answer should be compact. 0.94. What is the ratio of the % of total expenditure in primary institutions in Denmark in 2006 to that in 2011?
Keep it short and to the point. 0.96. What is the ratio of the % of total expenditure in primary institutions of Israel in 2006 to that in 2011?
Your response must be concise. 0.89. What is the ratio of the % of total expenditure in primary institutions in Uruguay in 2006 to that in 2011?
Your answer should be compact. 0.96. What is the difference between the highest and the second highest % of total expenditure in primary institutions in Denmark?
Keep it short and to the point. 3.02. What is the difference between the highest and the second highest % of total expenditure in primary institutions in Israel?
Provide a succinct answer. 6.49. What is the difference between the highest and the second highest % of total expenditure in primary institutions of Uruguay?
Make the answer very short. 1.78. What is the difference between the highest and the lowest % of total expenditure in primary institutions of Denmark?
Make the answer very short. 5.4. What is the difference between the highest and the lowest % of total expenditure in primary institutions of Israel?
Offer a terse response. 10.5. What is the difference between the highest and the lowest % of total expenditure in primary institutions in Uruguay?
Your answer should be compact. 24.87. 